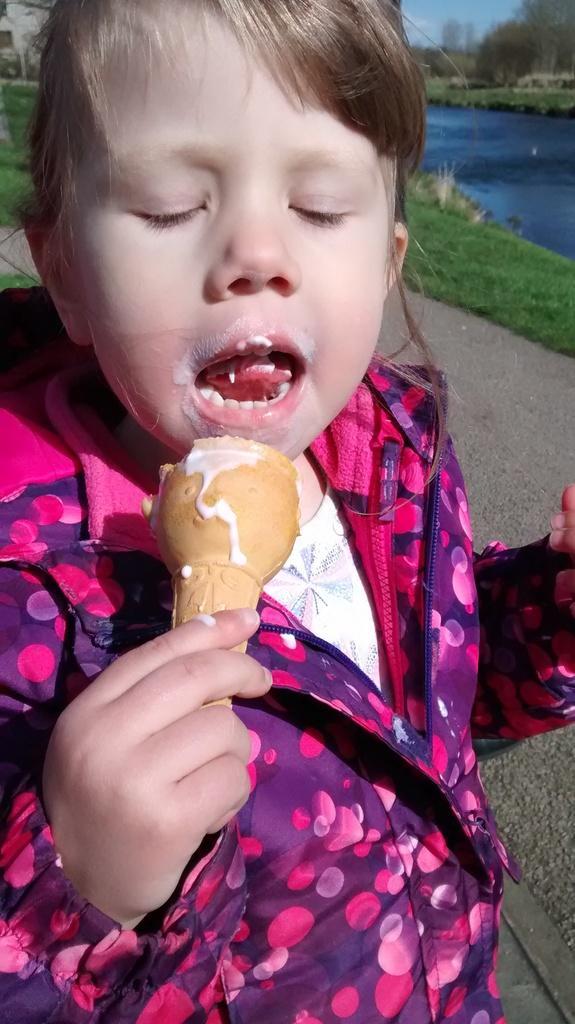In one or two sentences, can you explain what this image depicts? In this picture a girl is highlighted eating ice cream. She is wearing a pink colour jacket. On the background of the picture we can see a river and a green grass and also trees. 